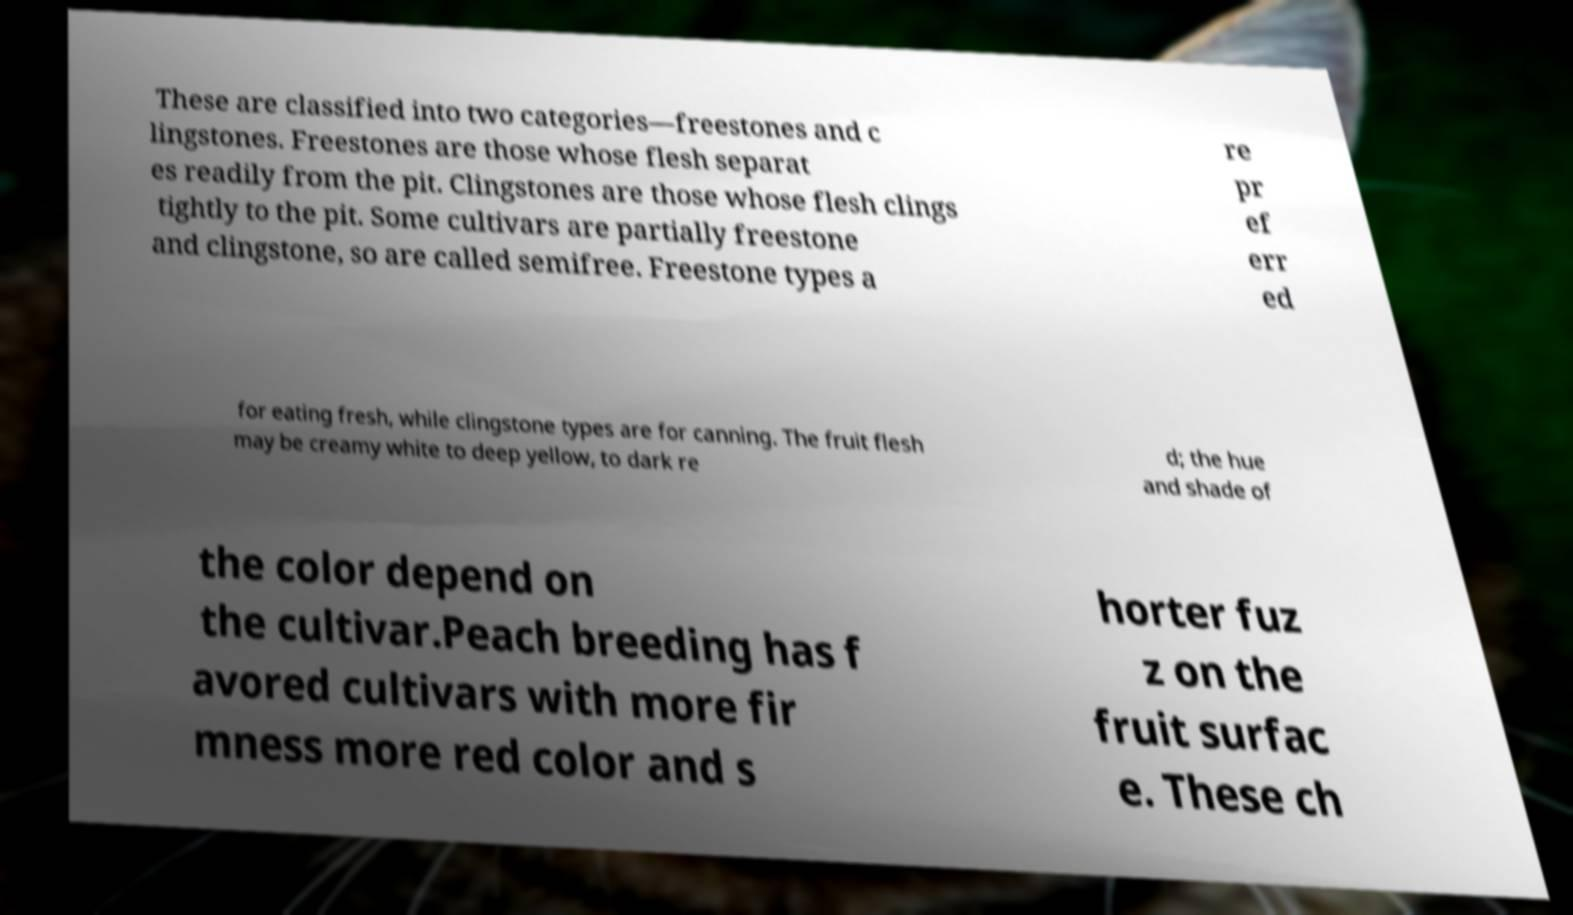I need the written content from this picture converted into text. Can you do that? These are classified into two categories—freestones and c lingstones. Freestones are those whose flesh separat es readily from the pit. Clingstones are those whose flesh clings tightly to the pit. Some cultivars are partially freestone and clingstone, so are called semifree. Freestone types a re pr ef err ed for eating fresh, while clingstone types are for canning. The fruit flesh may be creamy white to deep yellow, to dark re d; the hue and shade of the color depend on the cultivar.Peach breeding has f avored cultivars with more fir mness more red color and s horter fuz z on the fruit surfac e. These ch 